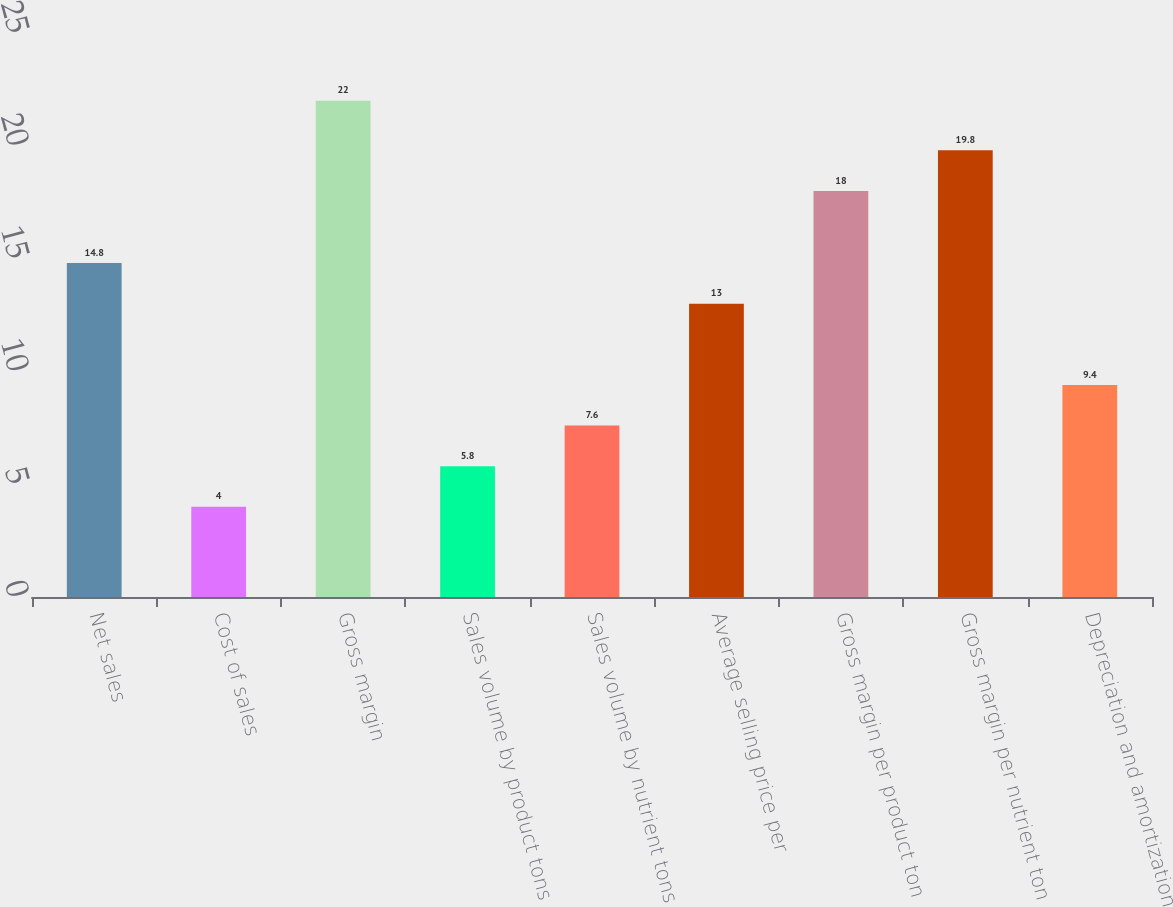Convert chart to OTSL. <chart><loc_0><loc_0><loc_500><loc_500><bar_chart><fcel>Net sales<fcel>Cost of sales<fcel>Gross margin<fcel>Sales volume by product tons<fcel>Sales volume by nutrient tons<fcel>Average selling price per<fcel>Gross margin per product ton<fcel>Gross margin per nutrient ton<fcel>Depreciation and amortization<nl><fcel>14.8<fcel>4<fcel>22<fcel>5.8<fcel>7.6<fcel>13<fcel>18<fcel>19.8<fcel>9.4<nl></chart> 